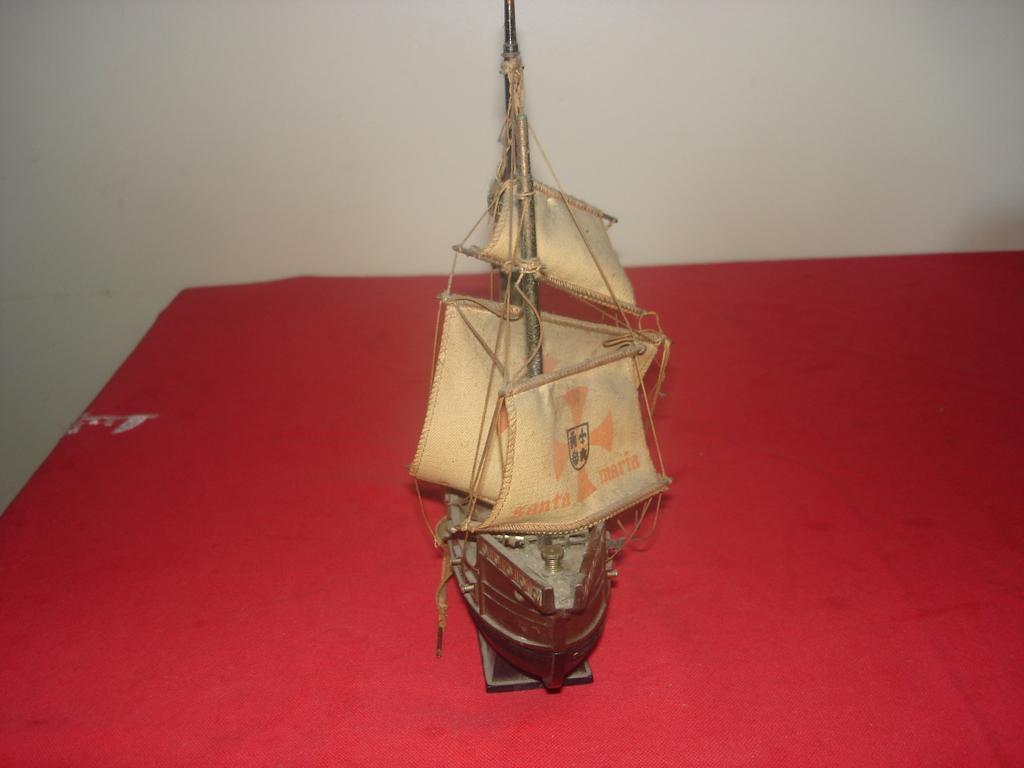Can you describe this image briefly? In the image we can see there is a ship toy kept on the table and behind there is a white colour wall. 